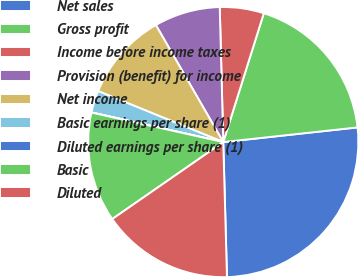<chart> <loc_0><loc_0><loc_500><loc_500><pie_chart><fcel>Net sales<fcel>Gross profit<fcel>Income before income taxes<fcel>Provision (benefit) for income<fcel>Net income<fcel>Basic earnings per share (1)<fcel>Diluted earnings per share (1)<fcel>Basic<fcel>Diluted<nl><fcel>26.3%<fcel>18.42%<fcel>5.27%<fcel>7.9%<fcel>10.53%<fcel>2.64%<fcel>0.01%<fcel>13.16%<fcel>15.79%<nl></chart> 